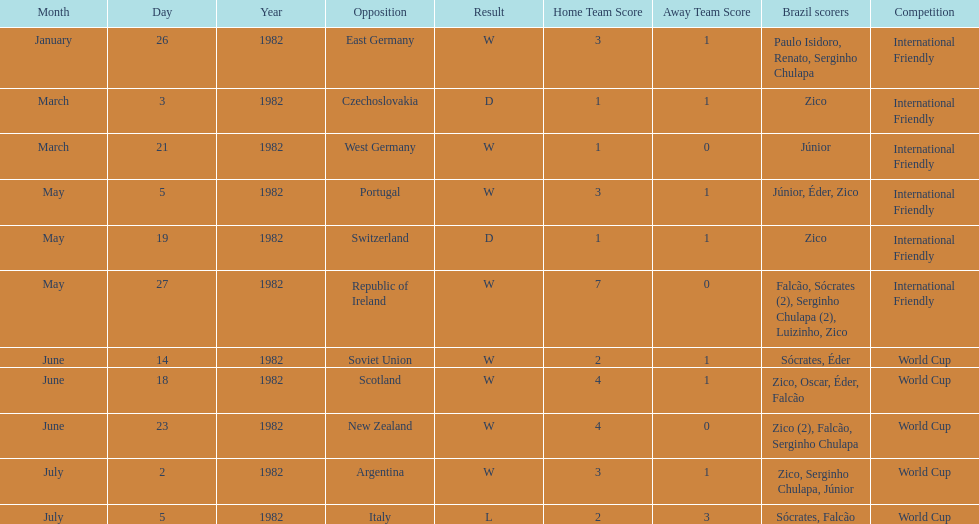What date is at the top of the list? January 26, 1982. 